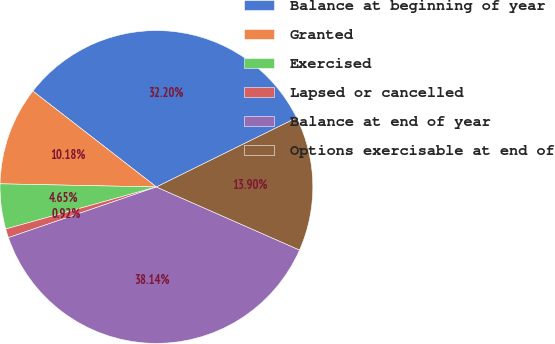Convert chart to OTSL. <chart><loc_0><loc_0><loc_500><loc_500><pie_chart><fcel>Balance at beginning of year<fcel>Granted<fcel>Exercised<fcel>Lapsed or cancelled<fcel>Balance at end of year<fcel>Options exercisable at end of<nl><fcel>32.2%<fcel>10.18%<fcel>4.65%<fcel>0.92%<fcel>38.14%<fcel>13.9%<nl></chart> 